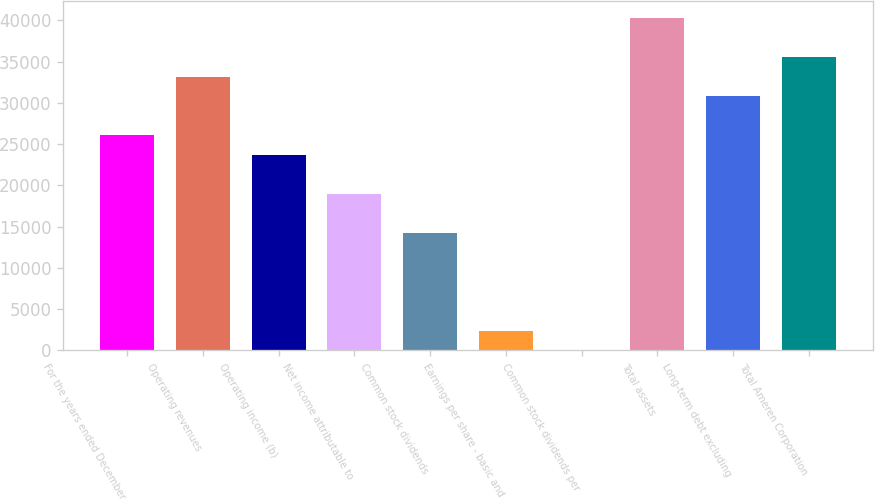Convert chart. <chart><loc_0><loc_0><loc_500><loc_500><bar_chart><fcel>For the years ended December<fcel>Operating revenues<fcel>Operating income (b)<fcel>Net income attributable to<fcel>Common stock dividends<fcel>Earnings per share - basic and<fcel>Common stock dividends per<fcel>Total assets<fcel>Long-term debt excluding<fcel>Total Ameren Corporation<nl><fcel>26072.1<fcel>33182.2<fcel>23702<fcel>18961.9<fcel>14221.8<fcel>2371.59<fcel>1.54<fcel>40292.4<fcel>30812.2<fcel>35552.3<nl></chart> 